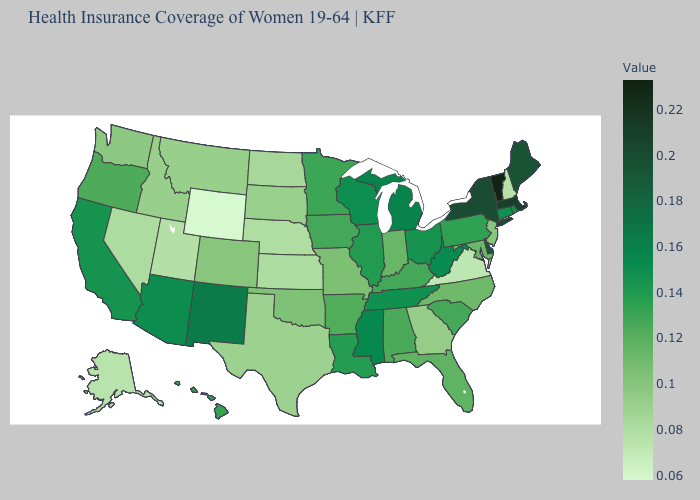Which states have the lowest value in the MidWest?
Be succinct. Nebraska. Does New Mexico have the highest value in the West?
Be succinct. Yes. Does Vermont have a higher value than Nebraska?
Answer briefly. Yes. Does the map have missing data?
Be succinct. No. 